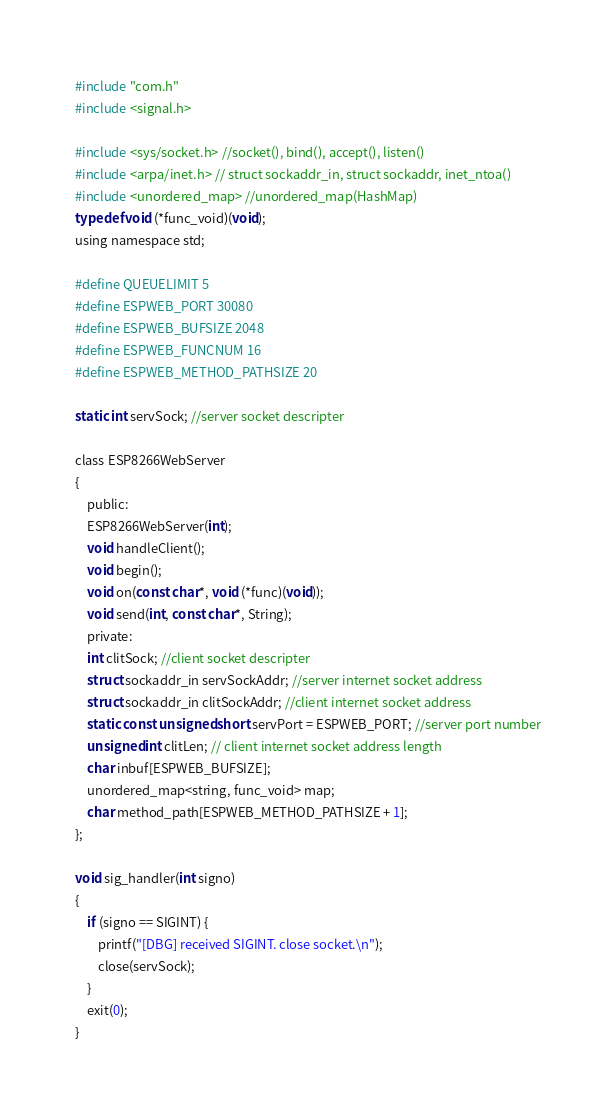Convert code to text. <code><loc_0><loc_0><loc_500><loc_500><_C_>#include "com.h"
#include <signal.h>

#include <sys/socket.h> //socket(), bind(), accept(), listen()
#include <arpa/inet.h> // struct sockaddr_in, struct sockaddr, inet_ntoa()
#include <unordered_map> //unordered_map(HashMap)
typedef void (*func_void)(void);
using namespace std;

#define QUEUELIMIT 5
#define ESPWEB_PORT 30080
#define ESPWEB_BUFSIZE 2048
#define ESPWEB_FUNCNUM 16
#define ESPWEB_METHOD_PATHSIZE 20

static int servSock; //server socket descripter

class ESP8266WebServer
{
	public:
	ESP8266WebServer(int);
	void handleClient();
	void begin();
	void on(const char*, void (*func)(void));
	void send(int, const char*, String);
	private:
	int clitSock; //client socket descripter
	struct sockaddr_in servSockAddr; //server internet socket address
	struct sockaddr_in clitSockAddr; //client internet socket address
	static const unsigned short servPort = ESPWEB_PORT; //server port number
	unsigned int clitLen; // client internet socket address length
	char inbuf[ESPWEB_BUFSIZE];
	unordered_map<string, func_void> map;
	char method_path[ESPWEB_METHOD_PATHSIZE + 1];
};

void sig_handler(int signo)
{
	if (signo == SIGINT) {
		printf("[DBG] received SIGINT. close socket.\n");
		close(servSock);
	}
	exit(0);
}
</code> 